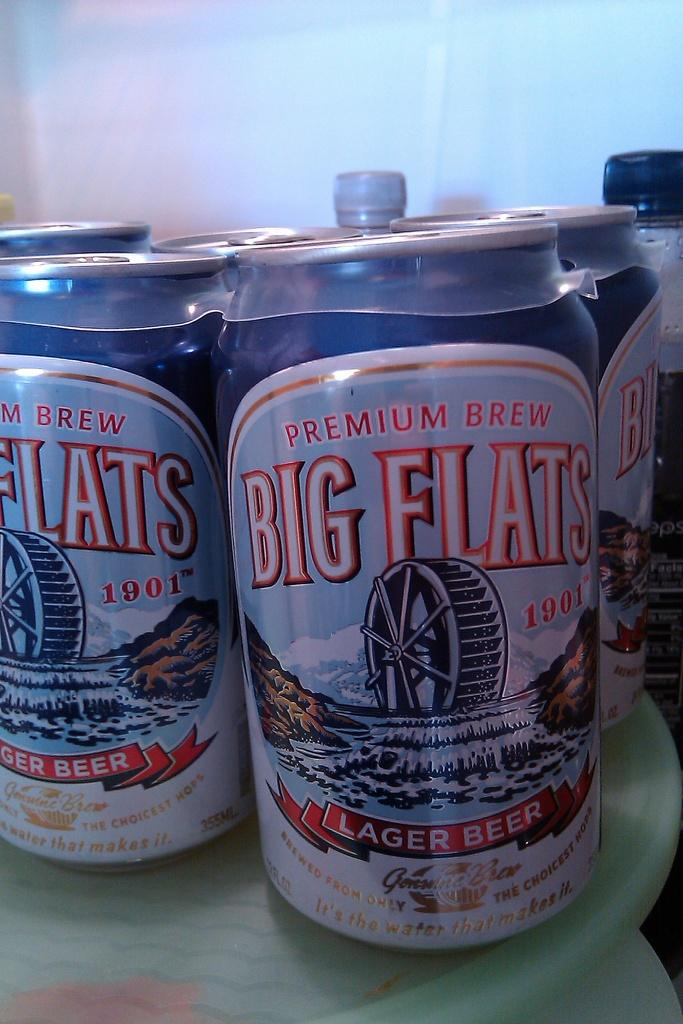<image>
Create a compact narrative representing the image presented. A can of premium brew Big Flats lager beer. 